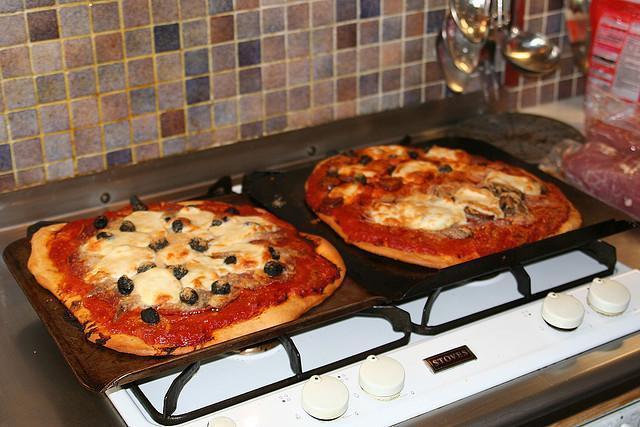How many pizzas are in the picture?
Give a very brief answer. 2. How many ovens are there?
Give a very brief answer. 1. 